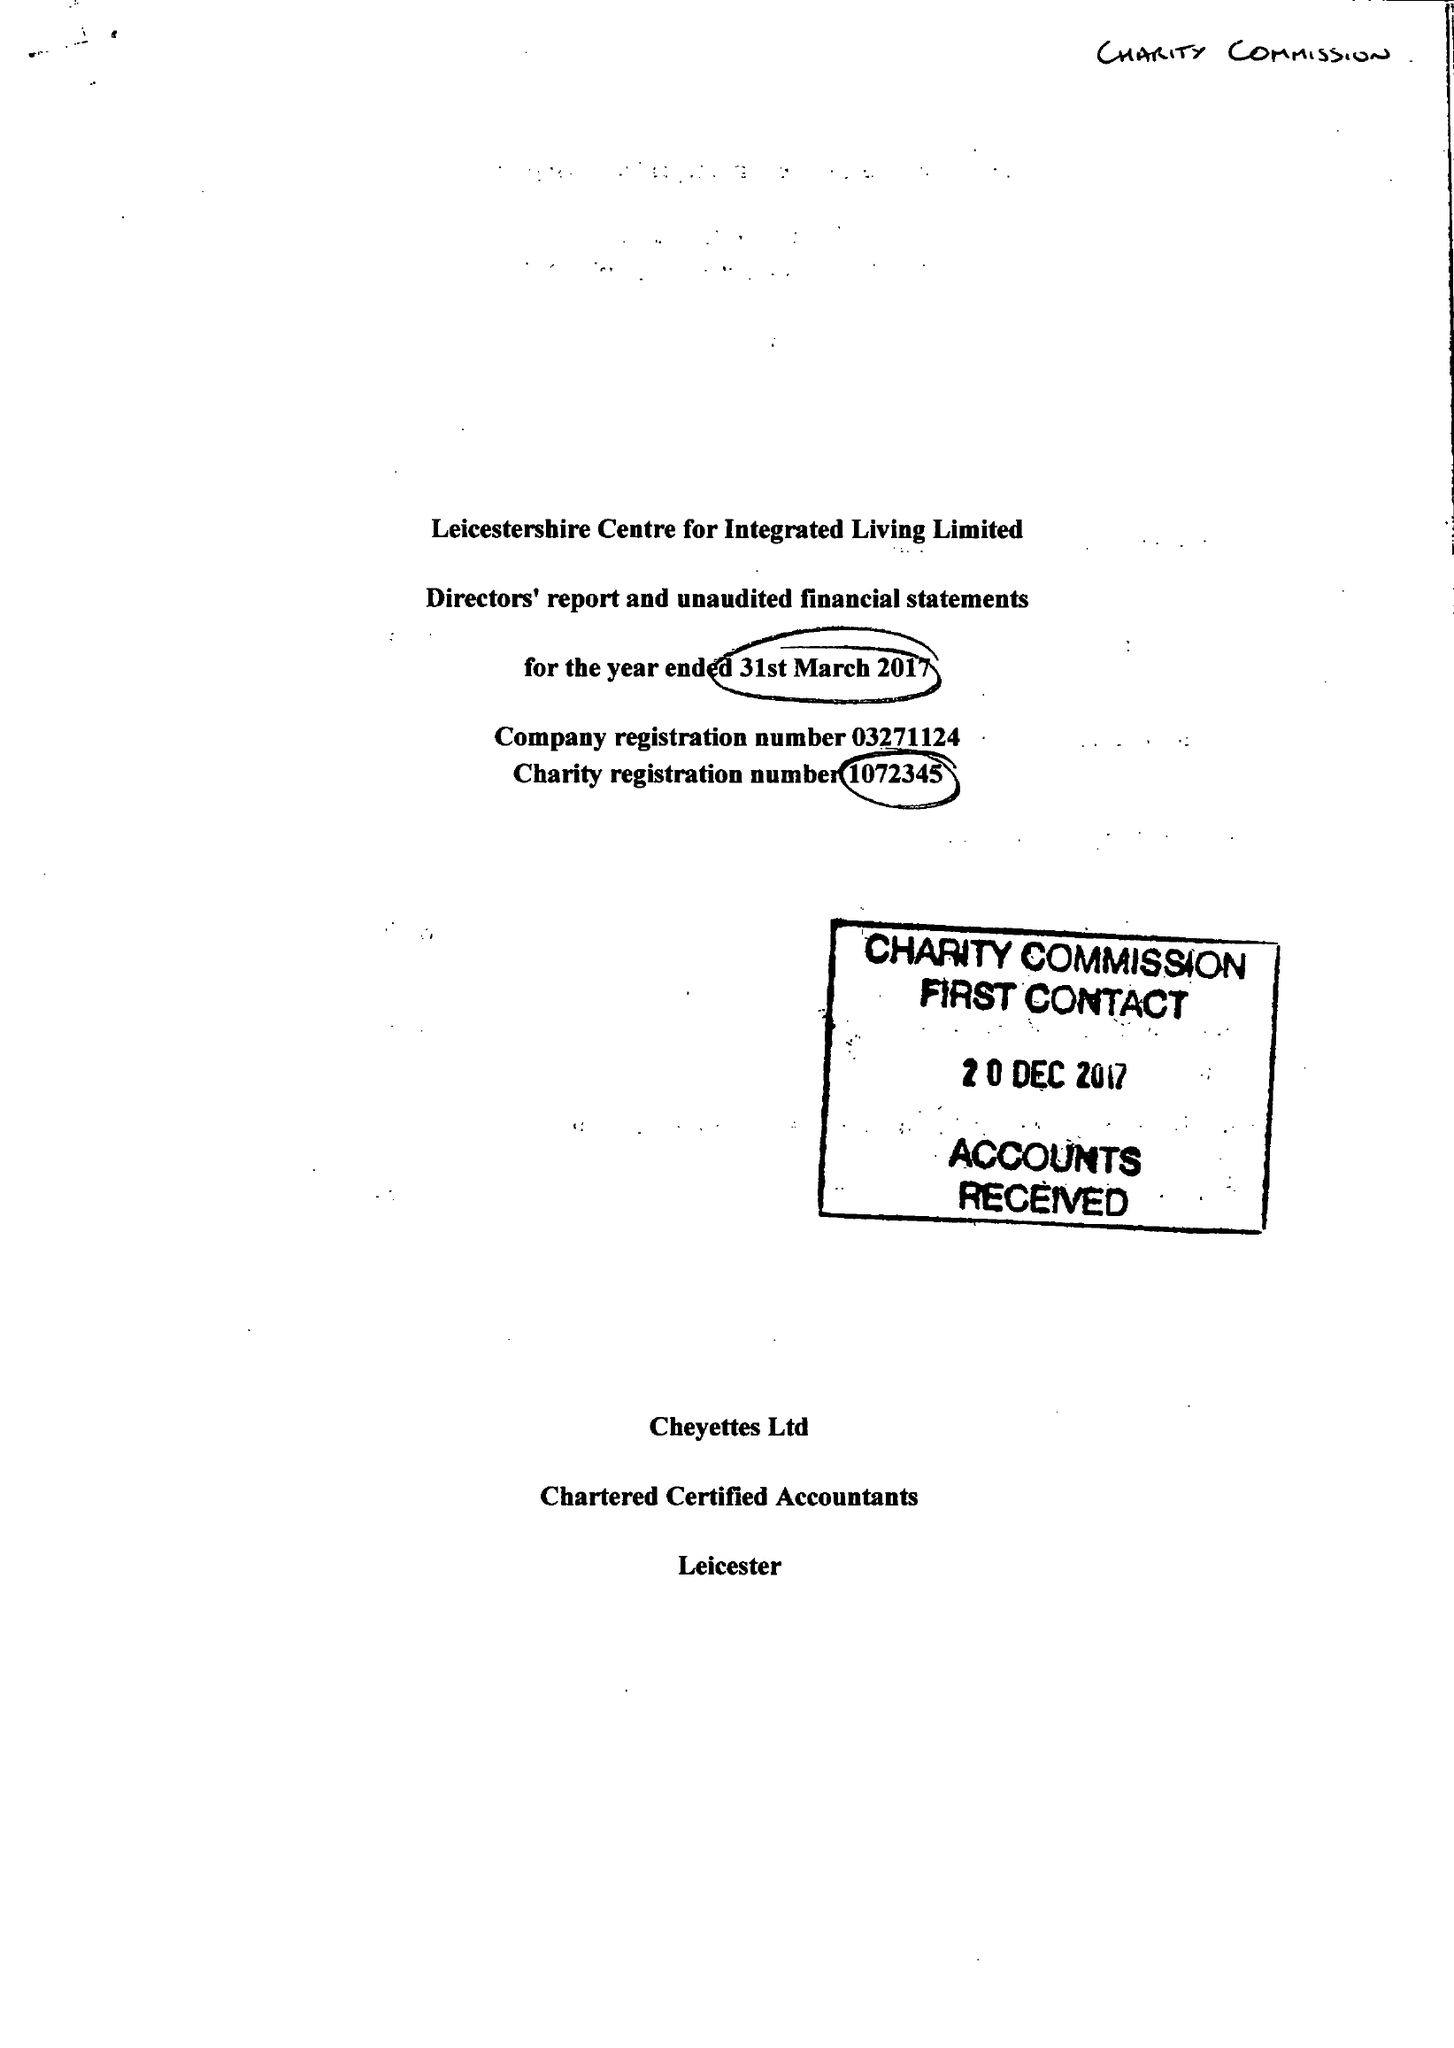What is the value for the address__street_line?
Answer the question using a single word or phrase. ANDREWES STREET 